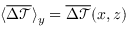Convert formula to latex. <formula><loc_0><loc_0><loc_500><loc_500>\langle \overline { { \Delta \mathcal { T } } } \rangle _ { y } = \overline { { \Delta \mathcal { T } } } ( x , z )</formula> 